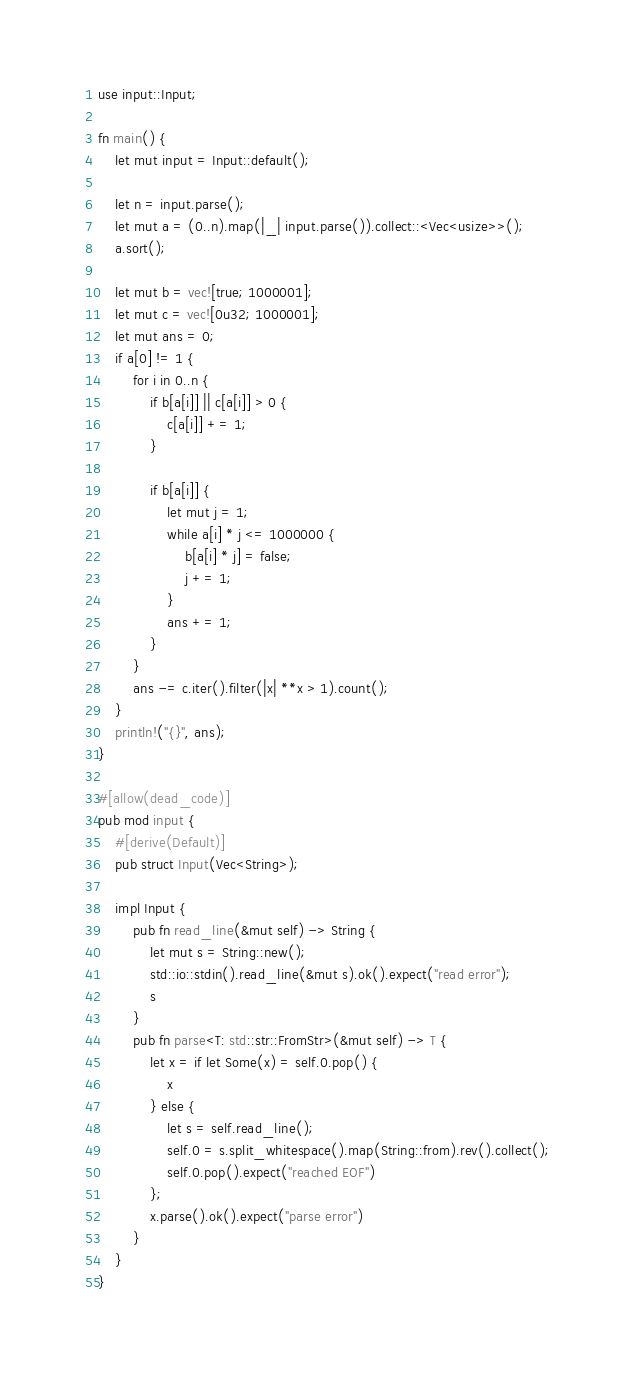Convert code to text. <code><loc_0><loc_0><loc_500><loc_500><_Rust_>use input::Input;

fn main() {
    let mut input = Input::default();

    let n = input.parse();
    let mut a = (0..n).map(|_| input.parse()).collect::<Vec<usize>>();
    a.sort();

    let mut b = vec![true; 1000001];
    let mut c = vec![0u32; 1000001];
    let mut ans = 0;
    if a[0] != 1 {
        for i in 0..n {
            if b[a[i]] || c[a[i]] > 0 {
                c[a[i]] += 1;
            }

            if b[a[i]] {
                let mut j = 1;
                while a[i] * j <= 1000000 {
                    b[a[i] * j] = false;
                    j += 1;
                }
                ans += 1;
            }
        }
        ans -= c.iter().filter(|x| **x > 1).count();
    }
    println!("{}", ans);
}

#[allow(dead_code)]
pub mod input {
    #[derive(Default)]
    pub struct Input(Vec<String>);

    impl Input {
        pub fn read_line(&mut self) -> String {
            let mut s = String::new();
            std::io::stdin().read_line(&mut s).ok().expect("read error");
            s
        }
        pub fn parse<T: std::str::FromStr>(&mut self) -> T {
            let x = if let Some(x) = self.0.pop() {
                x
            } else {
                let s = self.read_line();
                self.0 = s.split_whitespace().map(String::from).rev().collect();
                self.0.pop().expect("reached EOF")
            };
            x.parse().ok().expect("parse error")
        }
    }
}
</code> 